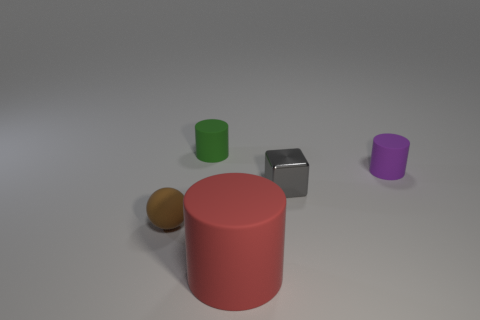Is the size of the green object the same as the purple rubber cylinder?
Your response must be concise. Yes. The thing that is both on the left side of the large rubber cylinder and behind the ball is what color?
Your response must be concise. Green. The gray thing has what size?
Ensure brevity in your answer.  Small. There is a cylinder that is to the right of the tiny gray metal object; does it have the same color as the metal cube?
Your answer should be very brief. No. Are there more green matte objects in front of the small ball than red cylinders right of the gray cube?
Your answer should be very brief. No. Is the number of big gray rubber balls greater than the number of tiny cylinders?
Offer a terse response. No. How big is the object that is both behind the gray block and to the right of the big thing?
Offer a terse response. Small. What shape is the red matte thing?
Offer a terse response. Cylinder. Is there anything else that is the same size as the red object?
Provide a short and direct response. No. Is the number of purple cylinders that are in front of the large matte cylinder greater than the number of large red cylinders?
Offer a very short reply. No. 